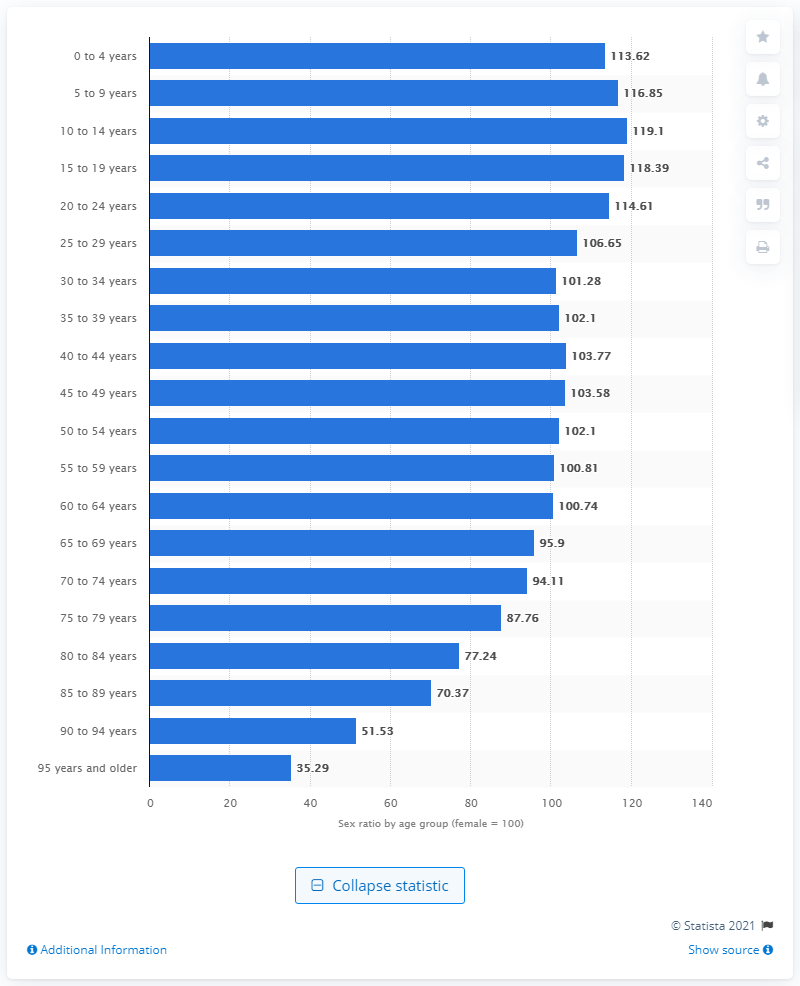Draw attention to some important aspects in this diagram. In 2019, there was a significant disparity between males and females in China, with a gender ratio of 119.1 males for every 100 females. 